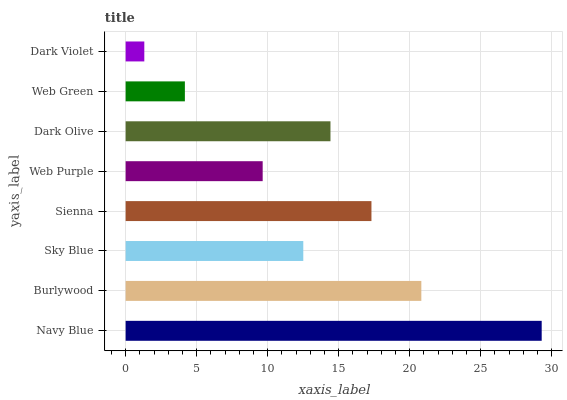Is Dark Violet the minimum?
Answer yes or no. Yes. Is Navy Blue the maximum?
Answer yes or no. Yes. Is Burlywood the minimum?
Answer yes or no. No. Is Burlywood the maximum?
Answer yes or no. No. Is Navy Blue greater than Burlywood?
Answer yes or no. Yes. Is Burlywood less than Navy Blue?
Answer yes or no. Yes. Is Burlywood greater than Navy Blue?
Answer yes or no. No. Is Navy Blue less than Burlywood?
Answer yes or no. No. Is Dark Olive the high median?
Answer yes or no. Yes. Is Sky Blue the low median?
Answer yes or no. Yes. Is Web Green the high median?
Answer yes or no. No. Is Web Purple the low median?
Answer yes or no. No. 